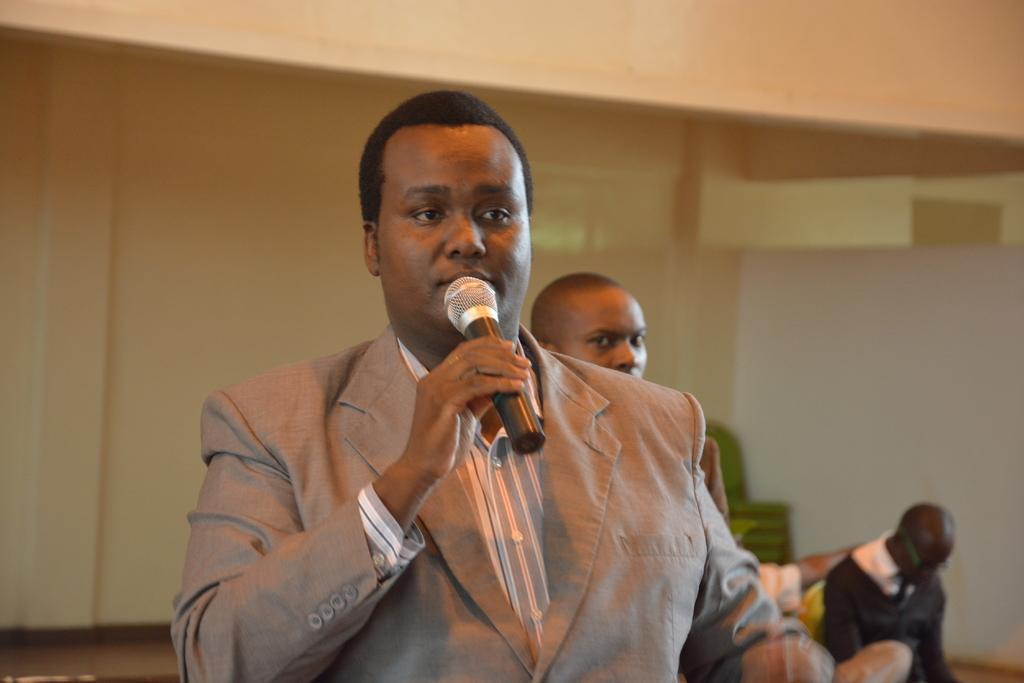What is the man in the image doing? The man is standing in the image and holding a microphone. What can be seen in the background of the image? There is a group of persons, a wall, and chairs in the background of the image. What might the man be using the microphone for? The man might be using the microphone for speaking or singing in front of the group of persons. What type of shop can be seen in the image? There is no shop present in the image. Is the man using a hammer in the image? No, the man is not using a hammer in the image; he is holding a microphone. 